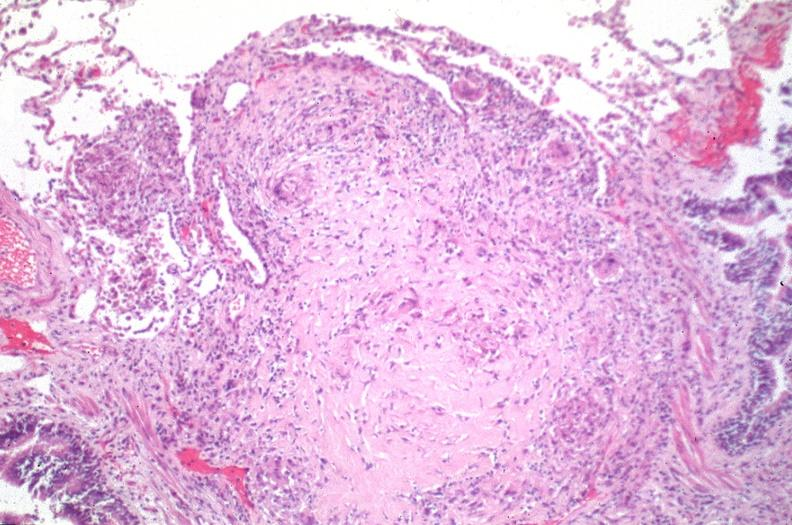does this image show lung, sarcoidosis, multinucleated giant cells?
Answer the question using a single word or phrase. Yes 